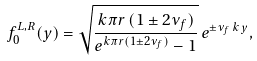<formula> <loc_0><loc_0><loc_500><loc_500>f _ { 0 } ^ { L , R } ( y ) = \sqrt { \frac { k \pi r \, ( 1 \pm 2 \nu _ { f } ) } { e ^ { k \pi r ( 1 \pm 2 \nu _ { f } ) } - 1 } } \, e ^ { \pm \nu _ { f } \, k \, y } ,</formula> 